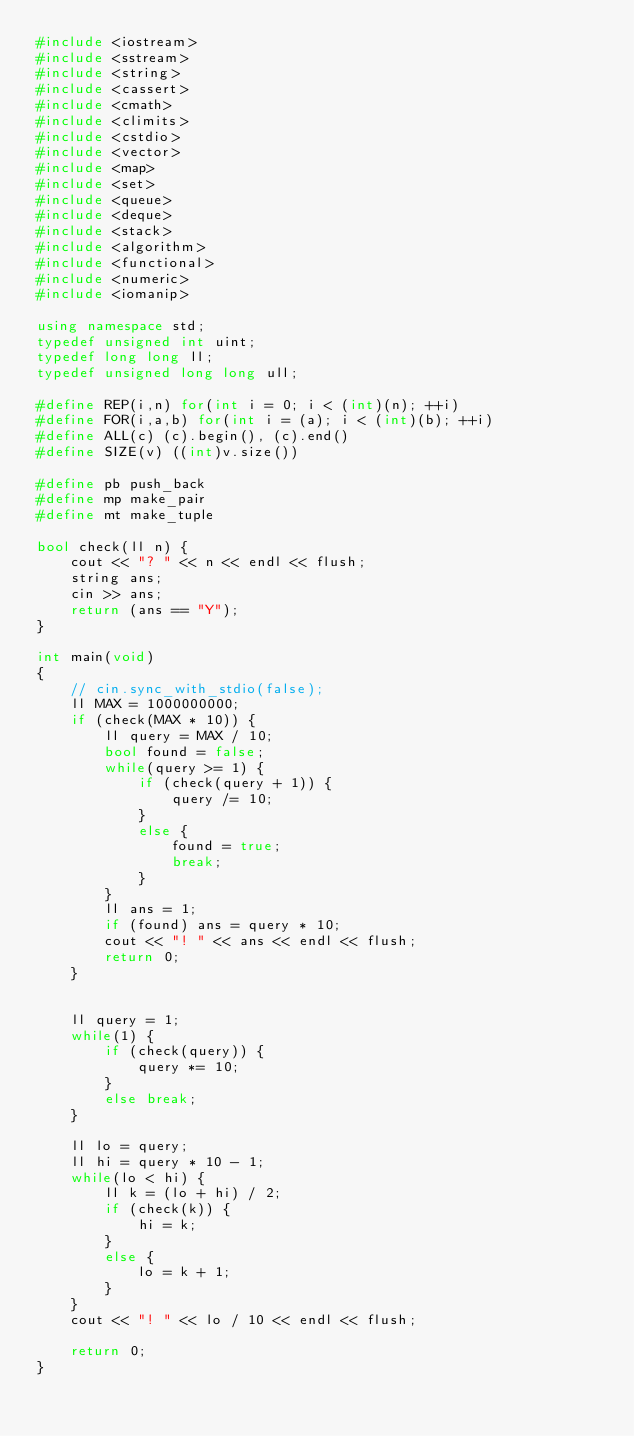Convert code to text. <code><loc_0><loc_0><loc_500><loc_500><_C++_>#include <iostream>
#include <sstream>
#include <string>
#include <cassert>
#include <cmath>
#include <climits>
#include <cstdio>
#include <vector>
#include <map>
#include <set>
#include <queue>
#include <deque>
#include <stack>
#include <algorithm>
#include <functional>
#include <numeric>
#include <iomanip>

using namespace std;
typedef unsigned int uint;
typedef long long ll;
typedef unsigned long long ull;

#define REP(i,n) for(int i = 0; i < (int)(n); ++i)
#define FOR(i,a,b) for(int i = (a); i < (int)(b); ++i)
#define ALL(c) (c).begin(), (c).end()
#define SIZE(v) ((int)v.size())

#define pb push_back
#define mp make_pair
#define mt make_tuple

bool check(ll n) {
    cout << "? " << n << endl << flush;
    string ans;
    cin >> ans;
    return (ans == "Y");
}

int main(void)
{
    // cin.sync_with_stdio(false);
    ll MAX = 1000000000;
    if (check(MAX * 10)) {
        ll query = MAX / 10;
        bool found = false;
        while(query >= 1) {
            if (check(query + 1)) {
                query /= 10;
            }
            else {
                found = true;
                break;
            }
        }
        ll ans = 1;
        if (found) ans = query * 10;
        cout << "! " << ans << endl << flush;
        return 0;
    }


    ll query = 1;
    while(1) {
        if (check(query)) {
            query *= 10;
        }
        else break;
    }
    
    ll lo = query;
    ll hi = query * 10 - 1;
    while(lo < hi) {
        ll k = (lo + hi) / 2;
        if (check(k)) {
            hi = k;
        }
        else {
            lo = k + 1;
        }
    }
    cout << "! " << lo / 10 << endl << flush;

    return 0;
}
</code> 